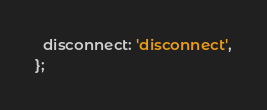<code> <loc_0><loc_0><loc_500><loc_500><_TypeScript_>  disconnect: 'disconnect',
};
</code> 